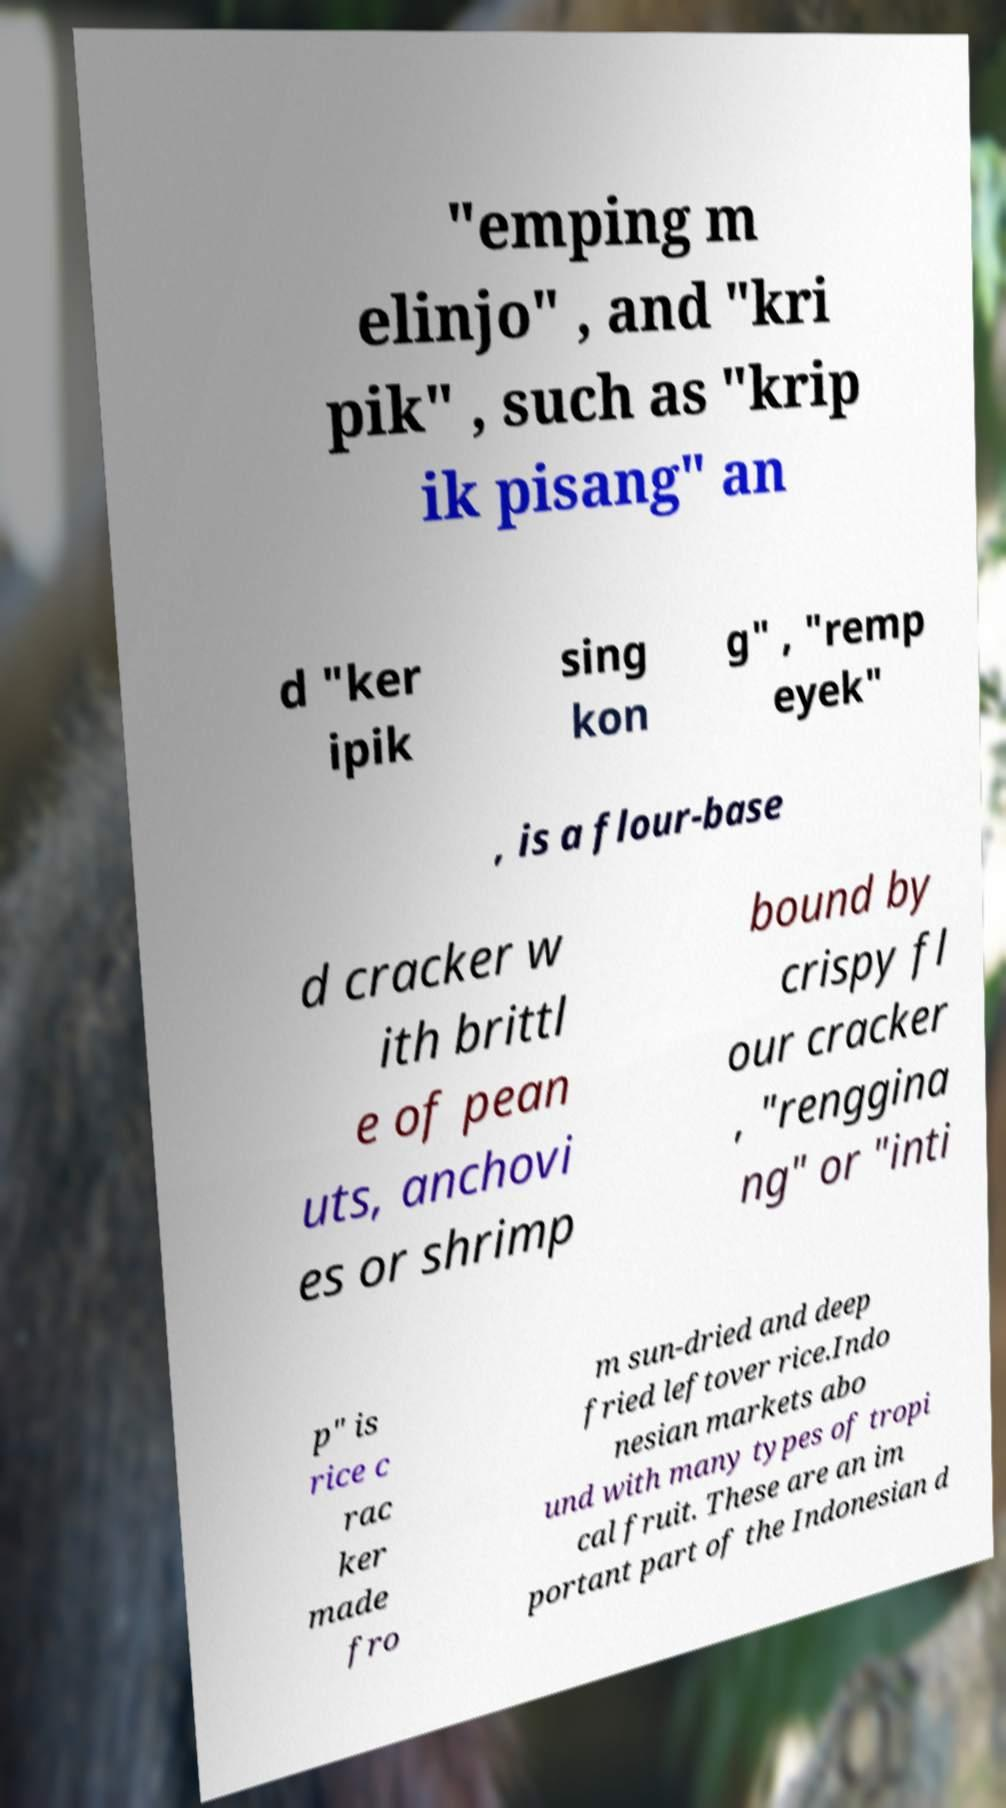For documentation purposes, I need the text within this image transcribed. Could you provide that? "emping m elinjo" , and "kri pik" , such as "krip ik pisang" an d "ker ipik sing kon g" , "remp eyek" , is a flour-base d cracker w ith brittl e of pean uts, anchovi es or shrimp bound by crispy fl our cracker , "renggina ng" or "inti p" is rice c rac ker made fro m sun-dried and deep fried leftover rice.Indo nesian markets abo und with many types of tropi cal fruit. These are an im portant part of the Indonesian d 